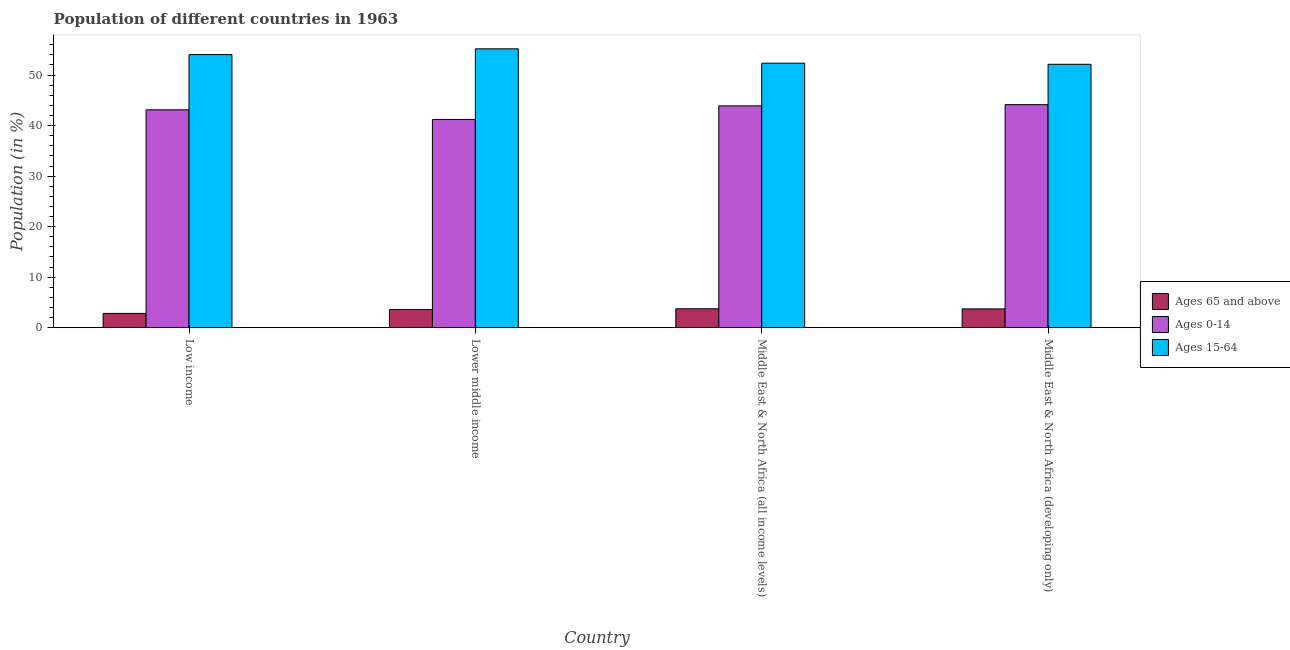How many groups of bars are there?
Provide a short and direct response. 4. Are the number of bars on each tick of the X-axis equal?
Give a very brief answer. Yes. How many bars are there on the 1st tick from the left?
Make the answer very short. 3. How many bars are there on the 4th tick from the right?
Make the answer very short. 3. What is the label of the 1st group of bars from the left?
Your response must be concise. Low income. What is the percentage of population within the age-group of 65 and above in Middle East & North Africa (all income levels)?
Provide a succinct answer. 3.74. Across all countries, what is the maximum percentage of population within the age-group 0-14?
Give a very brief answer. 44.15. Across all countries, what is the minimum percentage of population within the age-group 15-64?
Offer a very short reply. 52.13. In which country was the percentage of population within the age-group 0-14 maximum?
Your answer should be very brief. Middle East & North Africa (developing only). What is the total percentage of population within the age-group 0-14 in the graph?
Provide a short and direct response. 172.39. What is the difference between the percentage of population within the age-group 15-64 in Low income and that in Middle East & North Africa (all income levels)?
Offer a terse response. 1.7. What is the difference between the percentage of population within the age-group of 65 and above in Lower middle income and the percentage of population within the age-group 15-64 in Middle East & North Africa (all income levels)?
Ensure brevity in your answer.  -48.77. What is the average percentage of population within the age-group 0-14 per country?
Give a very brief answer. 43.1. What is the difference between the percentage of population within the age-group 15-64 and percentage of population within the age-group of 65 and above in Middle East & North Africa (developing only)?
Keep it short and to the point. 48.42. In how many countries, is the percentage of population within the age-group of 65 and above greater than 10 %?
Your response must be concise. 0. What is the ratio of the percentage of population within the age-group 0-14 in Lower middle income to that in Middle East & North Africa (all income levels)?
Your answer should be compact. 0.94. Is the difference between the percentage of population within the age-group 15-64 in Low income and Lower middle income greater than the difference between the percentage of population within the age-group of 65 and above in Low income and Lower middle income?
Make the answer very short. No. What is the difference between the highest and the second highest percentage of population within the age-group of 65 and above?
Make the answer very short. 0.02. What is the difference between the highest and the lowest percentage of population within the age-group of 65 and above?
Your answer should be compact. 0.92. Is the sum of the percentage of population within the age-group 0-14 in Lower middle income and Middle East & North Africa (developing only) greater than the maximum percentage of population within the age-group of 65 and above across all countries?
Keep it short and to the point. Yes. What does the 3rd bar from the left in Low income represents?
Offer a terse response. Ages 15-64. What does the 3rd bar from the right in Lower middle income represents?
Your answer should be very brief. Ages 65 and above. How many countries are there in the graph?
Offer a terse response. 4. What is the difference between two consecutive major ticks on the Y-axis?
Provide a short and direct response. 10. Are the values on the major ticks of Y-axis written in scientific E-notation?
Give a very brief answer. No. Does the graph contain any zero values?
Make the answer very short. No. Does the graph contain grids?
Make the answer very short. No. How many legend labels are there?
Your response must be concise. 3. How are the legend labels stacked?
Ensure brevity in your answer.  Vertical. What is the title of the graph?
Your answer should be very brief. Population of different countries in 1963. Does "Transport equipments" appear as one of the legend labels in the graph?
Offer a terse response. No. What is the Population (in %) in Ages 65 and above in Low income?
Provide a succinct answer. 2.82. What is the Population (in %) in Ages 0-14 in Low income?
Give a very brief answer. 43.12. What is the Population (in %) of Ages 15-64 in Low income?
Provide a succinct answer. 54.06. What is the Population (in %) of Ages 65 and above in Lower middle income?
Your response must be concise. 3.58. What is the Population (in %) of Ages 0-14 in Lower middle income?
Keep it short and to the point. 41.22. What is the Population (in %) in Ages 15-64 in Lower middle income?
Offer a terse response. 55.2. What is the Population (in %) in Ages 65 and above in Middle East & North Africa (all income levels)?
Keep it short and to the point. 3.74. What is the Population (in %) of Ages 0-14 in Middle East & North Africa (all income levels)?
Ensure brevity in your answer.  43.91. What is the Population (in %) of Ages 15-64 in Middle East & North Africa (all income levels)?
Your response must be concise. 52.35. What is the Population (in %) of Ages 65 and above in Middle East & North Africa (developing only)?
Provide a short and direct response. 3.72. What is the Population (in %) of Ages 0-14 in Middle East & North Africa (developing only)?
Ensure brevity in your answer.  44.15. What is the Population (in %) in Ages 15-64 in Middle East & North Africa (developing only)?
Offer a terse response. 52.13. Across all countries, what is the maximum Population (in %) of Ages 65 and above?
Provide a succinct answer. 3.74. Across all countries, what is the maximum Population (in %) of Ages 0-14?
Ensure brevity in your answer.  44.15. Across all countries, what is the maximum Population (in %) in Ages 15-64?
Ensure brevity in your answer.  55.2. Across all countries, what is the minimum Population (in %) in Ages 65 and above?
Make the answer very short. 2.82. Across all countries, what is the minimum Population (in %) in Ages 0-14?
Give a very brief answer. 41.22. Across all countries, what is the minimum Population (in %) in Ages 15-64?
Make the answer very short. 52.13. What is the total Population (in %) in Ages 65 and above in the graph?
Offer a terse response. 13.86. What is the total Population (in %) of Ages 0-14 in the graph?
Keep it short and to the point. 172.39. What is the total Population (in %) in Ages 15-64 in the graph?
Your response must be concise. 213.74. What is the difference between the Population (in %) of Ages 65 and above in Low income and that in Lower middle income?
Ensure brevity in your answer.  -0.76. What is the difference between the Population (in %) in Ages 0-14 in Low income and that in Lower middle income?
Ensure brevity in your answer.  1.91. What is the difference between the Population (in %) of Ages 15-64 in Low income and that in Lower middle income?
Keep it short and to the point. -1.14. What is the difference between the Population (in %) in Ages 65 and above in Low income and that in Middle East & North Africa (all income levels)?
Ensure brevity in your answer.  -0.92. What is the difference between the Population (in %) of Ages 0-14 in Low income and that in Middle East & North Africa (all income levels)?
Give a very brief answer. -0.78. What is the difference between the Population (in %) in Ages 15-64 in Low income and that in Middle East & North Africa (all income levels)?
Give a very brief answer. 1.7. What is the difference between the Population (in %) of Ages 65 and above in Low income and that in Middle East & North Africa (developing only)?
Your answer should be compact. -0.9. What is the difference between the Population (in %) of Ages 0-14 in Low income and that in Middle East & North Africa (developing only)?
Offer a terse response. -1.02. What is the difference between the Population (in %) of Ages 15-64 in Low income and that in Middle East & North Africa (developing only)?
Make the answer very short. 1.92. What is the difference between the Population (in %) of Ages 65 and above in Lower middle income and that in Middle East & North Africa (all income levels)?
Make the answer very short. -0.16. What is the difference between the Population (in %) of Ages 0-14 in Lower middle income and that in Middle East & North Africa (all income levels)?
Your answer should be compact. -2.69. What is the difference between the Population (in %) in Ages 15-64 in Lower middle income and that in Middle East & North Africa (all income levels)?
Make the answer very short. 2.85. What is the difference between the Population (in %) in Ages 65 and above in Lower middle income and that in Middle East & North Africa (developing only)?
Offer a terse response. -0.13. What is the difference between the Population (in %) in Ages 0-14 in Lower middle income and that in Middle East & North Africa (developing only)?
Offer a very short reply. -2.93. What is the difference between the Population (in %) of Ages 15-64 in Lower middle income and that in Middle East & North Africa (developing only)?
Provide a short and direct response. 3.07. What is the difference between the Population (in %) of Ages 65 and above in Middle East & North Africa (all income levels) and that in Middle East & North Africa (developing only)?
Provide a short and direct response. 0.02. What is the difference between the Population (in %) of Ages 0-14 in Middle East & North Africa (all income levels) and that in Middle East & North Africa (developing only)?
Your response must be concise. -0.24. What is the difference between the Population (in %) in Ages 15-64 in Middle East & North Africa (all income levels) and that in Middle East & North Africa (developing only)?
Offer a very short reply. 0.22. What is the difference between the Population (in %) in Ages 65 and above in Low income and the Population (in %) in Ages 0-14 in Lower middle income?
Your answer should be compact. -38.39. What is the difference between the Population (in %) of Ages 65 and above in Low income and the Population (in %) of Ages 15-64 in Lower middle income?
Offer a terse response. -52.38. What is the difference between the Population (in %) of Ages 0-14 in Low income and the Population (in %) of Ages 15-64 in Lower middle income?
Give a very brief answer. -12.08. What is the difference between the Population (in %) of Ages 65 and above in Low income and the Population (in %) of Ages 0-14 in Middle East & North Africa (all income levels)?
Ensure brevity in your answer.  -41.09. What is the difference between the Population (in %) of Ages 65 and above in Low income and the Population (in %) of Ages 15-64 in Middle East & North Africa (all income levels)?
Provide a short and direct response. -49.53. What is the difference between the Population (in %) in Ages 0-14 in Low income and the Population (in %) in Ages 15-64 in Middle East & North Africa (all income levels)?
Offer a terse response. -9.23. What is the difference between the Population (in %) in Ages 65 and above in Low income and the Population (in %) in Ages 0-14 in Middle East & North Africa (developing only)?
Provide a succinct answer. -41.33. What is the difference between the Population (in %) of Ages 65 and above in Low income and the Population (in %) of Ages 15-64 in Middle East & North Africa (developing only)?
Provide a short and direct response. -49.31. What is the difference between the Population (in %) of Ages 0-14 in Low income and the Population (in %) of Ages 15-64 in Middle East & North Africa (developing only)?
Make the answer very short. -9.01. What is the difference between the Population (in %) in Ages 65 and above in Lower middle income and the Population (in %) in Ages 0-14 in Middle East & North Africa (all income levels)?
Ensure brevity in your answer.  -40.32. What is the difference between the Population (in %) of Ages 65 and above in Lower middle income and the Population (in %) of Ages 15-64 in Middle East & North Africa (all income levels)?
Keep it short and to the point. -48.77. What is the difference between the Population (in %) of Ages 0-14 in Lower middle income and the Population (in %) of Ages 15-64 in Middle East & North Africa (all income levels)?
Provide a short and direct response. -11.14. What is the difference between the Population (in %) in Ages 65 and above in Lower middle income and the Population (in %) in Ages 0-14 in Middle East & North Africa (developing only)?
Your answer should be very brief. -40.56. What is the difference between the Population (in %) in Ages 65 and above in Lower middle income and the Population (in %) in Ages 15-64 in Middle East & North Africa (developing only)?
Keep it short and to the point. -48.55. What is the difference between the Population (in %) in Ages 0-14 in Lower middle income and the Population (in %) in Ages 15-64 in Middle East & North Africa (developing only)?
Ensure brevity in your answer.  -10.92. What is the difference between the Population (in %) of Ages 65 and above in Middle East & North Africa (all income levels) and the Population (in %) of Ages 0-14 in Middle East & North Africa (developing only)?
Your answer should be compact. -40.41. What is the difference between the Population (in %) in Ages 65 and above in Middle East & North Africa (all income levels) and the Population (in %) in Ages 15-64 in Middle East & North Africa (developing only)?
Keep it short and to the point. -48.4. What is the difference between the Population (in %) of Ages 0-14 in Middle East & North Africa (all income levels) and the Population (in %) of Ages 15-64 in Middle East & North Africa (developing only)?
Give a very brief answer. -8.23. What is the average Population (in %) of Ages 65 and above per country?
Make the answer very short. 3.47. What is the average Population (in %) of Ages 0-14 per country?
Ensure brevity in your answer.  43.1. What is the average Population (in %) in Ages 15-64 per country?
Provide a short and direct response. 53.44. What is the difference between the Population (in %) in Ages 65 and above and Population (in %) in Ages 0-14 in Low income?
Offer a very short reply. -40.3. What is the difference between the Population (in %) of Ages 65 and above and Population (in %) of Ages 15-64 in Low income?
Make the answer very short. -51.23. What is the difference between the Population (in %) of Ages 0-14 and Population (in %) of Ages 15-64 in Low income?
Offer a terse response. -10.93. What is the difference between the Population (in %) of Ages 65 and above and Population (in %) of Ages 0-14 in Lower middle income?
Your response must be concise. -37.63. What is the difference between the Population (in %) of Ages 65 and above and Population (in %) of Ages 15-64 in Lower middle income?
Provide a short and direct response. -51.62. What is the difference between the Population (in %) in Ages 0-14 and Population (in %) in Ages 15-64 in Lower middle income?
Make the answer very short. -13.98. What is the difference between the Population (in %) in Ages 65 and above and Population (in %) in Ages 0-14 in Middle East & North Africa (all income levels)?
Ensure brevity in your answer.  -40.17. What is the difference between the Population (in %) of Ages 65 and above and Population (in %) of Ages 15-64 in Middle East & North Africa (all income levels)?
Keep it short and to the point. -48.61. What is the difference between the Population (in %) in Ages 0-14 and Population (in %) in Ages 15-64 in Middle East & North Africa (all income levels)?
Make the answer very short. -8.45. What is the difference between the Population (in %) of Ages 65 and above and Population (in %) of Ages 0-14 in Middle East & North Africa (developing only)?
Ensure brevity in your answer.  -40.43. What is the difference between the Population (in %) of Ages 65 and above and Population (in %) of Ages 15-64 in Middle East & North Africa (developing only)?
Your response must be concise. -48.42. What is the difference between the Population (in %) in Ages 0-14 and Population (in %) in Ages 15-64 in Middle East & North Africa (developing only)?
Your answer should be compact. -7.99. What is the ratio of the Population (in %) in Ages 65 and above in Low income to that in Lower middle income?
Ensure brevity in your answer.  0.79. What is the ratio of the Population (in %) in Ages 0-14 in Low income to that in Lower middle income?
Provide a short and direct response. 1.05. What is the ratio of the Population (in %) of Ages 15-64 in Low income to that in Lower middle income?
Ensure brevity in your answer.  0.98. What is the ratio of the Population (in %) in Ages 65 and above in Low income to that in Middle East & North Africa (all income levels)?
Keep it short and to the point. 0.75. What is the ratio of the Population (in %) of Ages 0-14 in Low income to that in Middle East & North Africa (all income levels)?
Offer a terse response. 0.98. What is the ratio of the Population (in %) of Ages 15-64 in Low income to that in Middle East & North Africa (all income levels)?
Ensure brevity in your answer.  1.03. What is the ratio of the Population (in %) of Ages 65 and above in Low income to that in Middle East & North Africa (developing only)?
Keep it short and to the point. 0.76. What is the ratio of the Population (in %) of Ages 0-14 in Low income to that in Middle East & North Africa (developing only)?
Your answer should be compact. 0.98. What is the ratio of the Population (in %) of Ages 15-64 in Low income to that in Middle East & North Africa (developing only)?
Offer a terse response. 1.04. What is the ratio of the Population (in %) in Ages 65 and above in Lower middle income to that in Middle East & North Africa (all income levels)?
Provide a short and direct response. 0.96. What is the ratio of the Population (in %) in Ages 0-14 in Lower middle income to that in Middle East & North Africa (all income levels)?
Ensure brevity in your answer.  0.94. What is the ratio of the Population (in %) of Ages 15-64 in Lower middle income to that in Middle East & North Africa (all income levels)?
Ensure brevity in your answer.  1.05. What is the ratio of the Population (in %) of Ages 65 and above in Lower middle income to that in Middle East & North Africa (developing only)?
Offer a terse response. 0.96. What is the ratio of the Population (in %) in Ages 0-14 in Lower middle income to that in Middle East & North Africa (developing only)?
Your response must be concise. 0.93. What is the ratio of the Population (in %) in Ages 15-64 in Lower middle income to that in Middle East & North Africa (developing only)?
Offer a terse response. 1.06. What is the ratio of the Population (in %) in Ages 65 and above in Middle East & North Africa (all income levels) to that in Middle East & North Africa (developing only)?
Make the answer very short. 1.01. What is the ratio of the Population (in %) in Ages 15-64 in Middle East & North Africa (all income levels) to that in Middle East & North Africa (developing only)?
Your answer should be very brief. 1. What is the difference between the highest and the second highest Population (in %) in Ages 65 and above?
Keep it short and to the point. 0.02. What is the difference between the highest and the second highest Population (in %) in Ages 0-14?
Ensure brevity in your answer.  0.24. What is the difference between the highest and the second highest Population (in %) of Ages 15-64?
Make the answer very short. 1.14. What is the difference between the highest and the lowest Population (in %) of Ages 65 and above?
Offer a terse response. 0.92. What is the difference between the highest and the lowest Population (in %) in Ages 0-14?
Keep it short and to the point. 2.93. What is the difference between the highest and the lowest Population (in %) of Ages 15-64?
Make the answer very short. 3.07. 